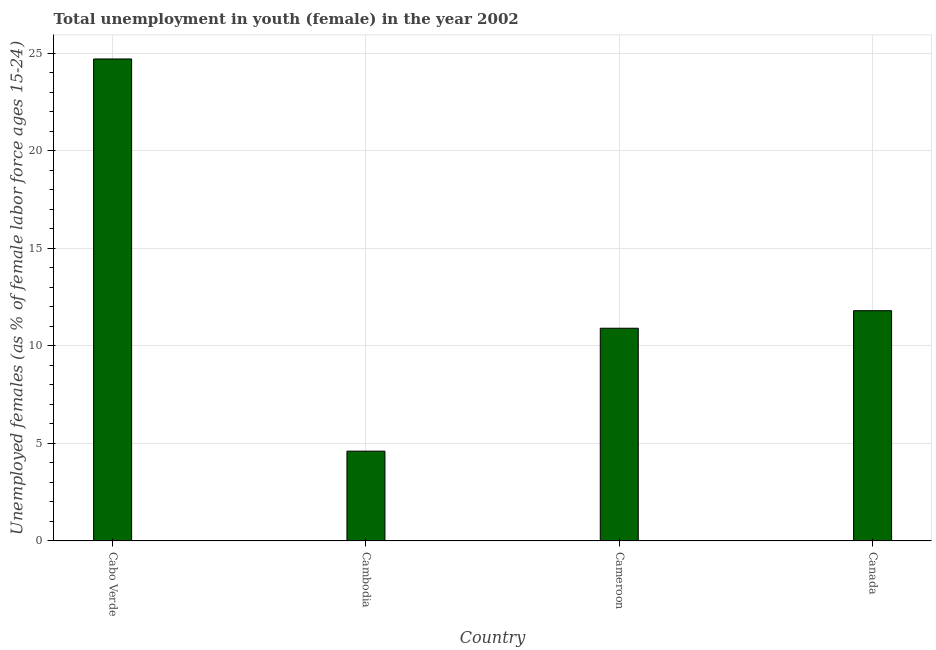Does the graph contain any zero values?
Ensure brevity in your answer.  No. Does the graph contain grids?
Make the answer very short. Yes. What is the title of the graph?
Your response must be concise. Total unemployment in youth (female) in the year 2002. What is the label or title of the X-axis?
Give a very brief answer. Country. What is the label or title of the Y-axis?
Your response must be concise. Unemployed females (as % of female labor force ages 15-24). What is the unemployed female youth population in Canada?
Your answer should be compact. 11.8. Across all countries, what is the maximum unemployed female youth population?
Give a very brief answer. 24.7. Across all countries, what is the minimum unemployed female youth population?
Provide a short and direct response. 4.6. In which country was the unemployed female youth population maximum?
Ensure brevity in your answer.  Cabo Verde. In which country was the unemployed female youth population minimum?
Offer a terse response. Cambodia. What is the sum of the unemployed female youth population?
Your response must be concise. 52. What is the difference between the unemployed female youth population in Cameroon and Canada?
Offer a very short reply. -0.9. What is the average unemployed female youth population per country?
Offer a terse response. 13. What is the median unemployed female youth population?
Provide a succinct answer. 11.35. What is the ratio of the unemployed female youth population in Cabo Verde to that in Cameroon?
Make the answer very short. 2.27. Is the unemployed female youth population in Cabo Verde less than that in Cameroon?
Ensure brevity in your answer.  No. Is the difference between the unemployed female youth population in Cabo Verde and Canada greater than the difference between any two countries?
Provide a succinct answer. No. What is the difference between the highest and the second highest unemployed female youth population?
Provide a short and direct response. 12.9. Is the sum of the unemployed female youth population in Cameroon and Canada greater than the maximum unemployed female youth population across all countries?
Give a very brief answer. No. What is the difference between the highest and the lowest unemployed female youth population?
Offer a terse response. 20.1. In how many countries, is the unemployed female youth population greater than the average unemployed female youth population taken over all countries?
Provide a succinct answer. 1. How many bars are there?
Offer a terse response. 4. What is the Unemployed females (as % of female labor force ages 15-24) of Cabo Verde?
Provide a succinct answer. 24.7. What is the Unemployed females (as % of female labor force ages 15-24) in Cambodia?
Give a very brief answer. 4.6. What is the Unemployed females (as % of female labor force ages 15-24) in Cameroon?
Your answer should be compact. 10.9. What is the Unemployed females (as % of female labor force ages 15-24) of Canada?
Make the answer very short. 11.8. What is the difference between the Unemployed females (as % of female labor force ages 15-24) in Cabo Verde and Cambodia?
Give a very brief answer. 20.1. What is the difference between the Unemployed females (as % of female labor force ages 15-24) in Cabo Verde and Cameroon?
Provide a succinct answer. 13.8. What is the difference between the Unemployed females (as % of female labor force ages 15-24) in Cambodia and Cameroon?
Offer a very short reply. -6.3. What is the difference between the Unemployed females (as % of female labor force ages 15-24) in Cameroon and Canada?
Your response must be concise. -0.9. What is the ratio of the Unemployed females (as % of female labor force ages 15-24) in Cabo Verde to that in Cambodia?
Keep it short and to the point. 5.37. What is the ratio of the Unemployed females (as % of female labor force ages 15-24) in Cabo Verde to that in Cameroon?
Make the answer very short. 2.27. What is the ratio of the Unemployed females (as % of female labor force ages 15-24) in Cabo Verde to that in Canada?
Make the answer very short. 2.09. What is the ratio of the Unemployed females (as % of female labor force ages 15-24) in Cambodia to that in Cameroon?
Offer a very short reply. 0.42. What is the ratio of the Unemployed females (as % of female labor force ages 15-24) in Cambodia to that in Canada?
Keep it short and to the point. 0.39. What is the ratio of the Unemployed females (as % of female labor force ages 15-24) in Cameroon to that in Canada?
Offer a terse response. 0.92. 